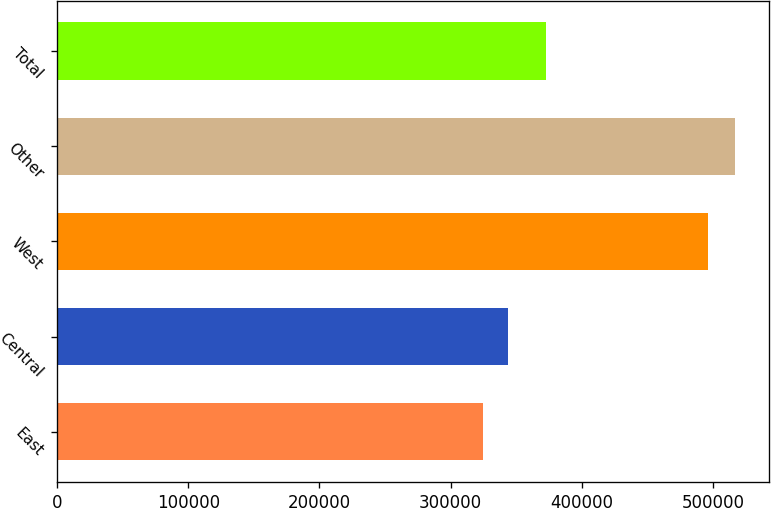<chart> <loc_0><loc_0><loc_500><loc_500><bar_chart><fcel>East<fcel>Central<fcel>West<fcel>Other<fcel>Total<nl><fcel>325000<fcel>344200<fcel>496000<fcel>517000<fcel>373000<nl></chart> 